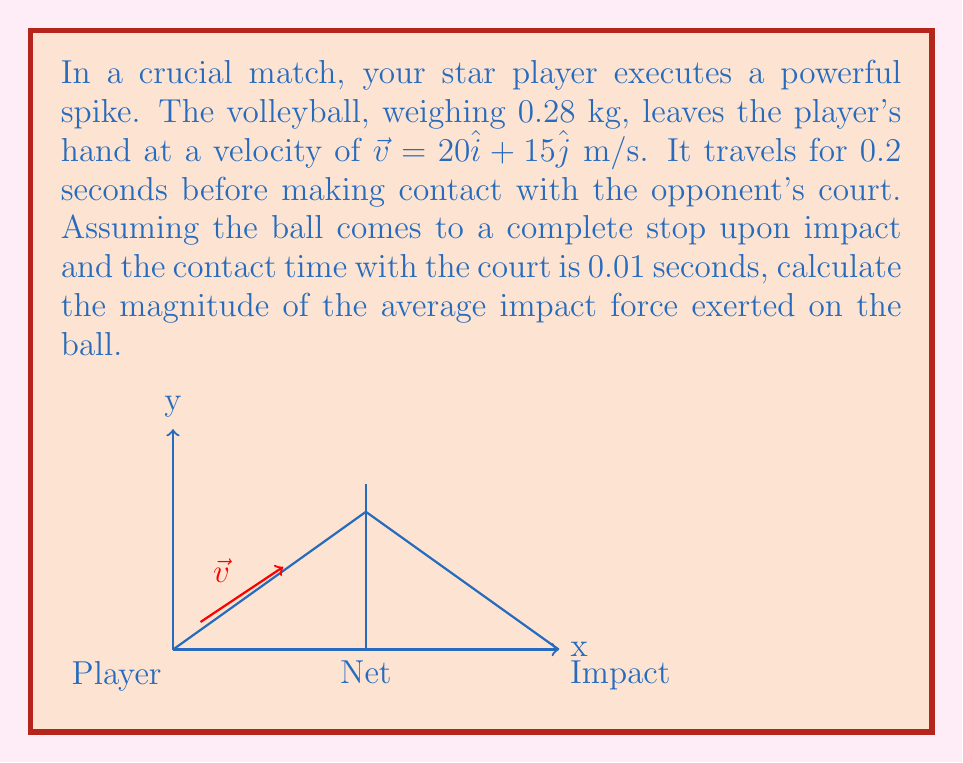Solve this math problem. Let's approach this step-by-step using vector operations and kinematics:

1) First, we need to find the final velocity vector just before impact. We can use the equation:
   $$\vec{v}_f = \vec{v}_i + \vec{a}t$$
   
   Where $\vec{a} = -9.8\hat{j}$ m/s² (gravity), and $t = 0.2$ s.
   
   $$\vec{v}_f = (20\hat{i} + 15\hat{j}) + (-9.8\hat{j})(0.2)$$
   $$\vec{v}_f = 20\hat{i} + 13.04\hat{j}$$ m/s

2) Now we can calculate the change in velocity:
   $$\Delta\vec{v} = \vec{v}_f - \vec{v}_i = (20\hat{i} + 13.04\hat{j}) - (0\hat{i} + 0\hat{j})$$
   $$\Delta\vec{v} = 20\hat{i} + 13.04\hat{j}$$ m/s

3) The magnitude of this change in velocity is:
   $$|\Delta\vec{v}| = \sqrt{20^2 + 13.04^2} = 23.89$$ m/s

4) We can use the impulse-momentum theorem to find the average force:
   $$\vec{F}_{avg} \Delta t = m\Delta\vec{v}$$

5) Rearranging for $\vec{F}_{avg}$:
   $$\vec{F}_{avg} = \frac{m\Delta\vec{v}}{\Delta t}$$

6) Substituting the values:
   $$\vec{F}_{avg} = \frac{0.28 \cdot 23.89}{0.01} = 668.92$$ N

7) The magnitude of this force is 668.92 N.
Answer: 668.92 N 